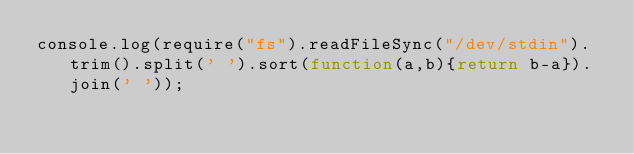<code> <loc_0><loc_0><loc_500><loc_500><_JavaScript_>console.log(require("fs").readFileSync("/dev/stdin").trim().split(' ').sort(function(a,b){return b-a}).join(' '));</code> 